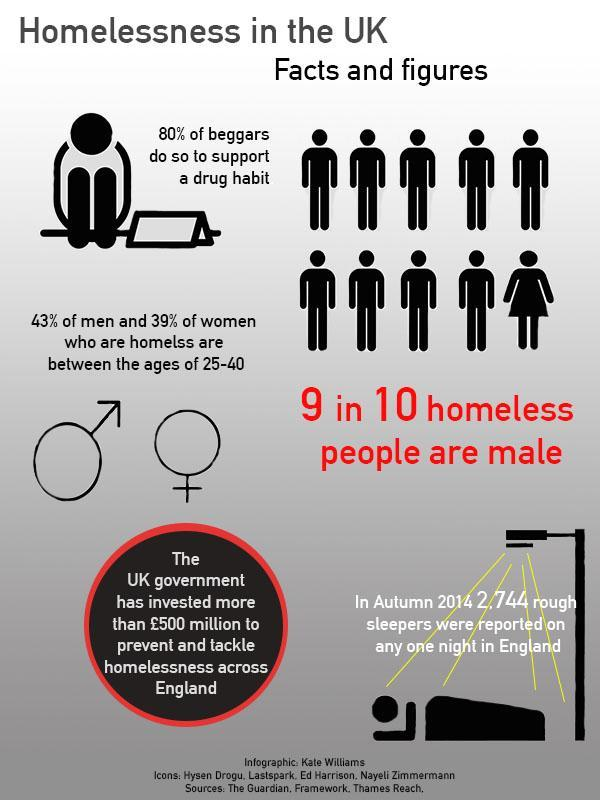What is the predominant age of 43% of homeless men?
Answer the question with a short phrase. 25-40 What is the predominant age of 39% of homeless women? 25-40 What percentage of beggars do not beg to support a drug habit? 20% How many homeless people are male? 90% 